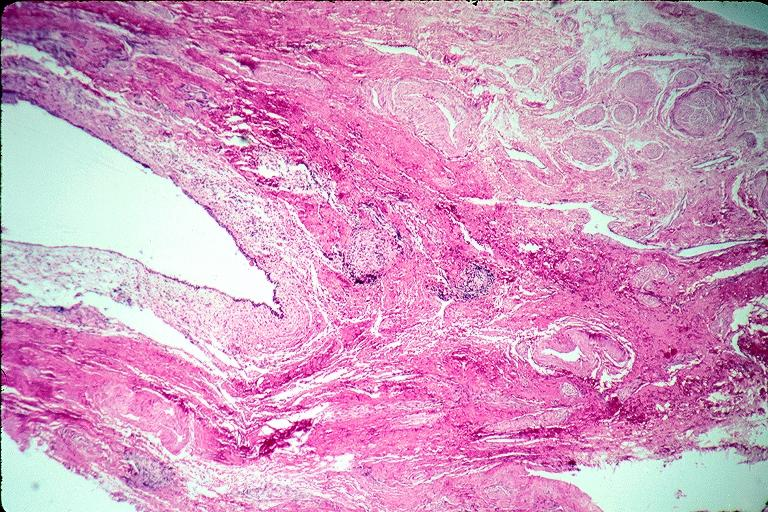what does this image show?
Answer the question using a single word or phrase. Incisive canal cyst nasopalatien duct cyst 